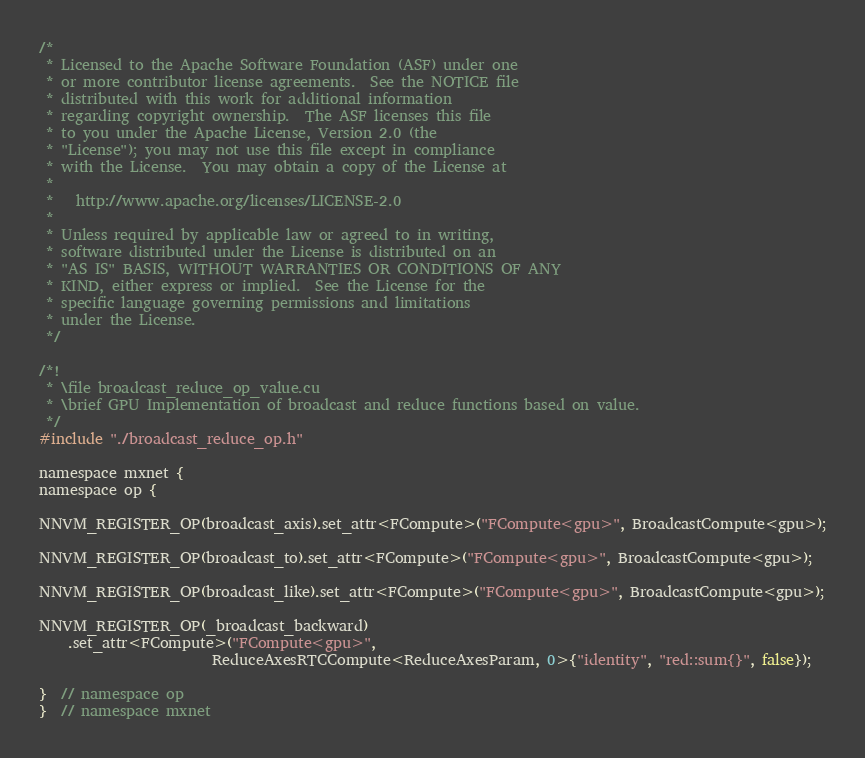Convert code to text. <code><loc_0><loc_0><loc_500><loc_500><_Cuda_>/*
 * Licensed to the Apache Software Foundation (ASF) under one
 * or more contributor license agreements.  See the NOTICE file
 * distributed with this work for additional information
 * regarding copyright ownership.  The ASF licenses this file
 * to you under the Apache License, Version 2.0 (the
 * "License"); you may not use this file except in compliance
 * with the License.  You may obtain a copy of the License at
 *
 *   http://www.apache.org/licenses/LICENSE-2.0
 *
 * Unless required by applicable law or agreed to in writing,
 * software distributed under the License is distributed on an
 * "AS IS" BASIS, WITHOUT WARRANTIES OR CONDITIONS OF ANY
 * KIND, either express or implied.  See the License for the
 * specific language governing permissions and limitations
 * under the License.
 */

/*!
 * \file broadcast_reduce_op_value.cu
 * \brief GPU Implementation of broadcast and reduce functions based on value.
 */
#include "./broadcast_reduce_op.h"

namespace mxnet {
namespace op {

NNVM_REGISTER_OP(broadcast_axis).set_attr<FCompute>("FCompute<gpu>", BroadcastCompute<gpu>);

NNVM_REGISTER_OP(broadcast_to).set_attr<FCompute>("FCompute<gpu>", BroadcastCompute<gpu>);

NNVM_REGISTER_OP(broadcast_like).set_attr<FCompute>("FCompute<gpu>", BroadcastCompute<gpu>);

NNVM_REGISTER_OP(_broadcast_backward)
    .set_attr<FCompute>("FCompute<gpu>",
                        ReduceAxesRTCCompute<ReduceAxesParam, 0>{"identity", "red::sum{}", false});

}  // namespace op
}  // namespace mxnet
</code> 